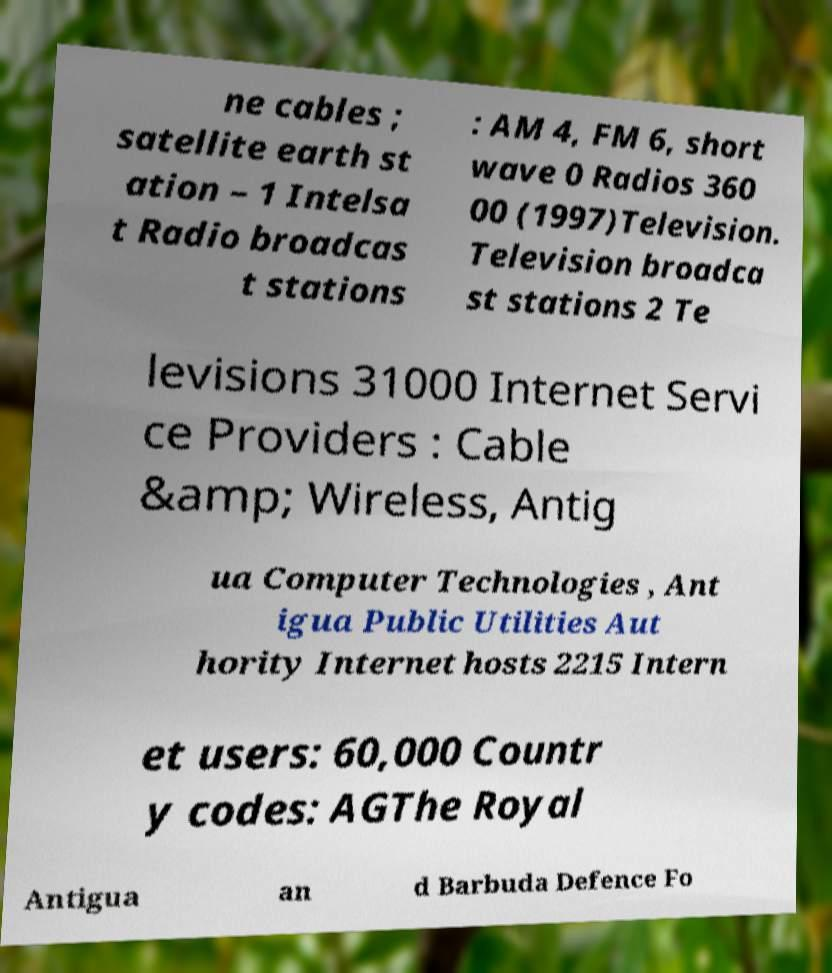For documentation purposes, I need the text within this image transcribed. Could you provide that? ne cables ; satellite earth st ation – 1 Intelsa t Radio broadcas t stations : AM 4, FM 6, short wave 0 Radios 360 00 (1997)Television. Television broadca st stations 2 Te levisions 31000 Internet Servi ce Providers : Cable &amp; Wireless, Antig ua Computer Technologies , Ant igua Public Utilities Aut hority Internet hosts 2215 Intern et users: 60,000 Countr y codes: AGThe Royal Antigua an d Barbuda Defence Fo 